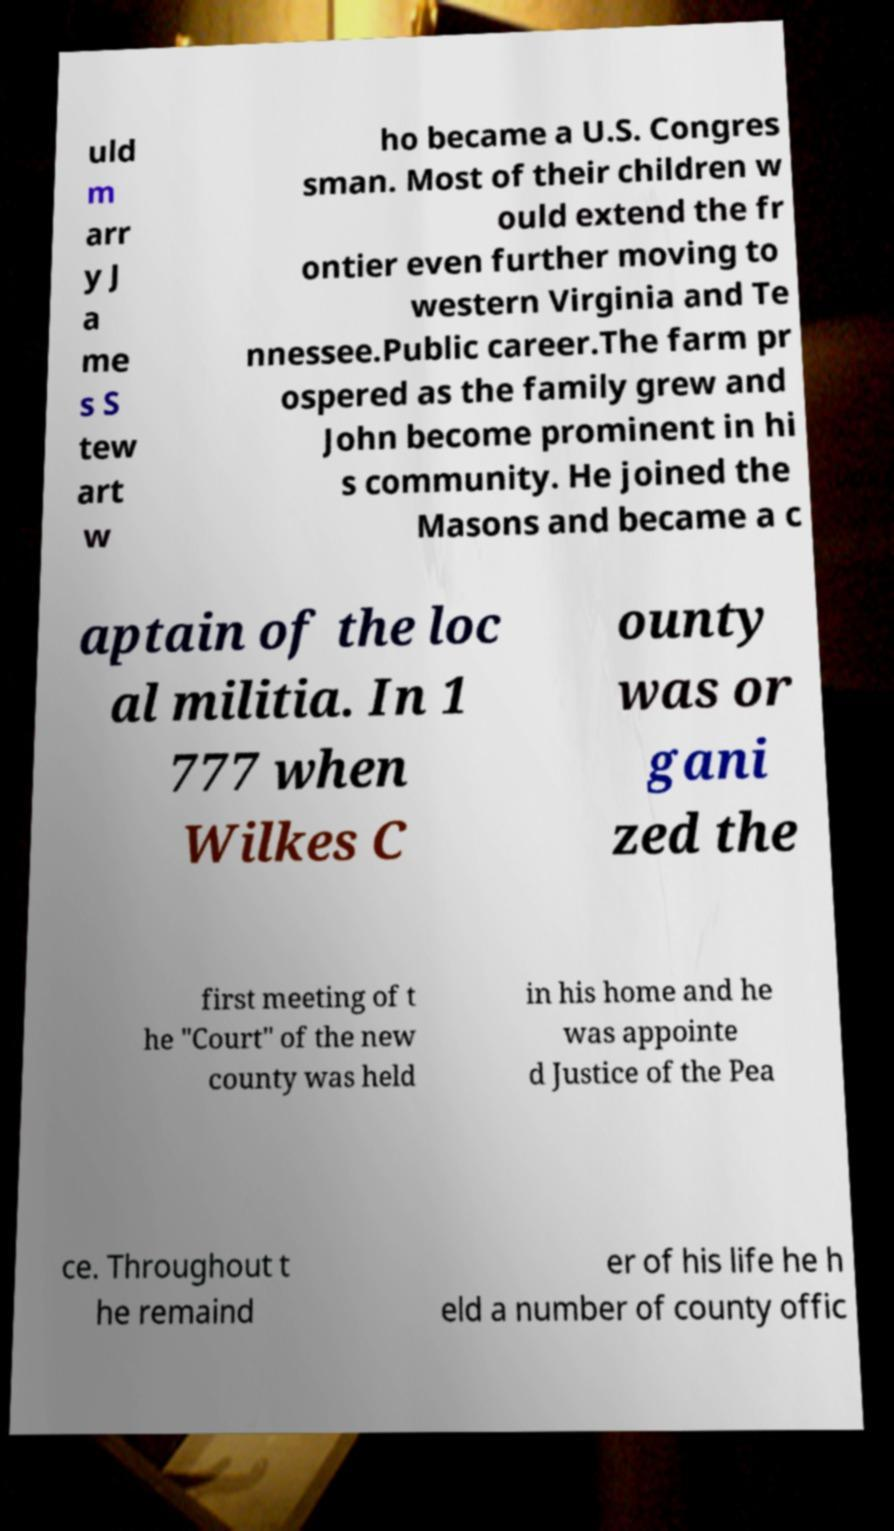For documentation purposes, I need the text within this image transcribed. Could you provide that? uld m arr y J a me s S tew art w ho became a U.S. Congres sman. Most of their children w ould extend the fr ontier even further moving to western Virginia and Te nnessee.Public career.The farm pr ospered as the family grew and John become prominent in hi s community. He joined the Masons and became a c aptain of the loc al militia. In 1 777 when Wilkes C ounty was or gani zed the first meeting of t he "Court" of the new county was held in his home and he was appointe d Justice of the Pea ce. Throughout t he remaind er of his life he h eld a number of county offic 